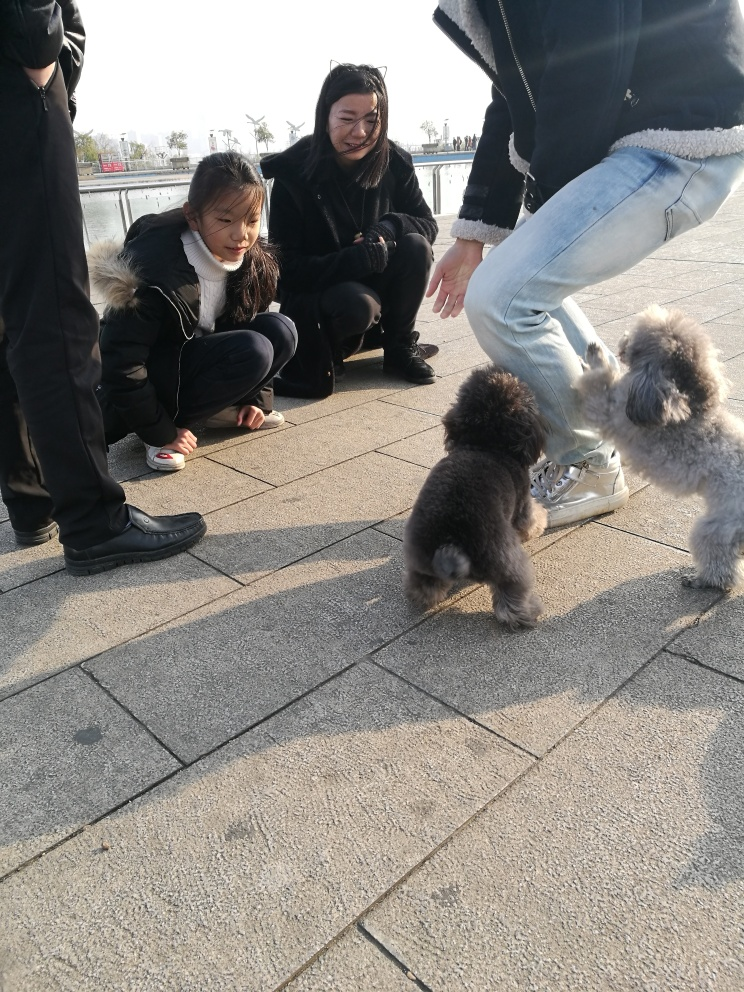Can you describe the setting and time of day this photo might have been taken? The photo appears to have been taken outdoors in a public space, possibly a park or waterside promenade, as suggested by the rays of sunlight and the open space in the background. The shadows are soft, which could indicate that this was captured in the early morning or late afternoon when the sun is lower in the sky, creating a less intense light and longer shadows. Does the setting seem to be busy or relaxed? The setting gives off a relaxed vibe, as there are only a few people in the immediate vicinity, and they all seem to be focused on the dogs. The absence of a crowd and the open area convey a tranquil atmosphere where individuals can enjoy a moment of leisure without the hustle and bustle of a busy environment. 